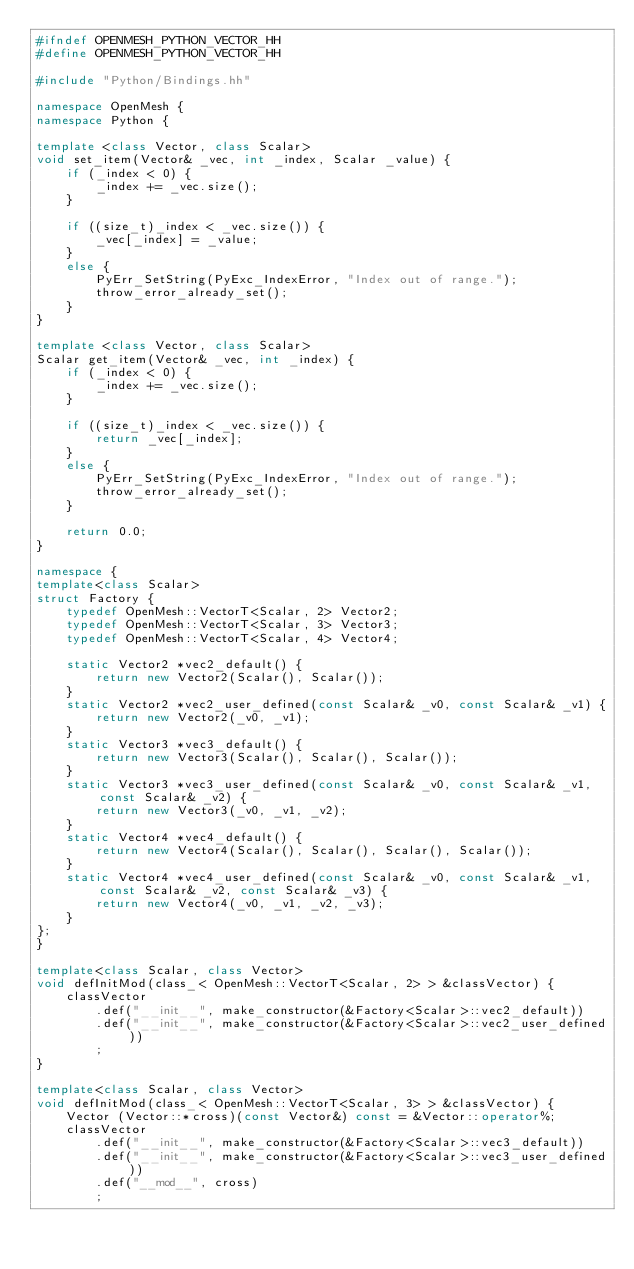<code> <loc_0><loc_0><loc_500><loc_500><_C++_>#ifndef OPENMESH_PYTHON_VECTOR_HH
#define OPENMESH_PYTHON_VECTOR_HH

#include "Python/Bindings.hh"

namespace OpenMesh {
namespace Python {

template <class Vector, class Scalar>
void set_item(Vector& _vec, int _index, Scalar _value) {
	if (_index < 0) {
		_index += _vec.size();
	}

	if ((size_t)_index < _vec.size()) {
		_vec[_index] = _value;
	}
	else {
		PyErr_SetString(PyExc_IndexError, "Index out of range.");
		throw_error_already_set();
	}
}

template <class Vector, class Scalar>
Scalar get_item(Vector& _vec, int _index) {
	if (_index < 0) {
		_index += _vec.size();
	}

	if ((size_t)_index < _vec.size()) {
		return _vec[_index];
	}
	else {
		PyErr_SetString(PyExc_IndexError, "Index out of range.");
		throw_error_already_set();
	}

	return 0.0;
}

namespace {
template<class Scalar>
struct Factory {
	typedef OpenMesh::VectorT<Scalar, 2> Vector2;
	typedef OpenMesh::VectorT<Scalar, 3> Vector3;
	typedef OpenMesh::VectorT<Scalar, 4> Vector4;

	static Vector2 *vec2_default() {
		return new Vector2(Scalar(), Scalar());
	}
	static Vector2 *vec2_user_defined(const Scalar& _v0, const Scalar& _v1) {
		return new Vector2(_v0, _v1);
	}
	static Vector3 *vec3_default() {
		return new Vector3(Scalar(), Scalar(), Scalar());
	}
	static Vector3 *vec3_user_defined(const Scalar& _v0, const Scalar& _v1, const Scalar& _v2) {
		return new Vector3(_v0, _v1, _v2);
	}
	static Vector4 *vec4_default() {
		return new Vector4(Scalar(), Scalar(), Scalar(), Scalar());
	}
	static Vector4 *vec4_user_defined(const Scalar& _v0, const Scalar& _v1, const Scalar& _v2, const Scalar& _v3) {
		return new Vector4(_v0, _v1, _v2, _v3);
	}
};
}

template<class Scalar, class Vector>
void defInitMod(class_< OpenMesh::VectorT<Scalar, 2> > &classVector) {
	classVector
		.def("__init__", make_constructor(&Factory<Scalar>::vec2_default))
		.def("__init__", make_constructor(&Factory<Scalar>::vec2_user_defined))
		;
}

template<class Scalar, class Vector>
void defInitMod(class_< OpenMesh::VectorT<Scalar, 3> > &classVector) {
	Vector (Vector::*cross)(const Vector&) const = &Vector::operator%;
	classVector
		.def("__init__", make_constructor(&Factory<Scalar>::vec3_default))
		.def("__init__", make_constructor(&Factory<Scalar>::vec3_user_defined))
		.def("__mod__", cross)
		;</code> 